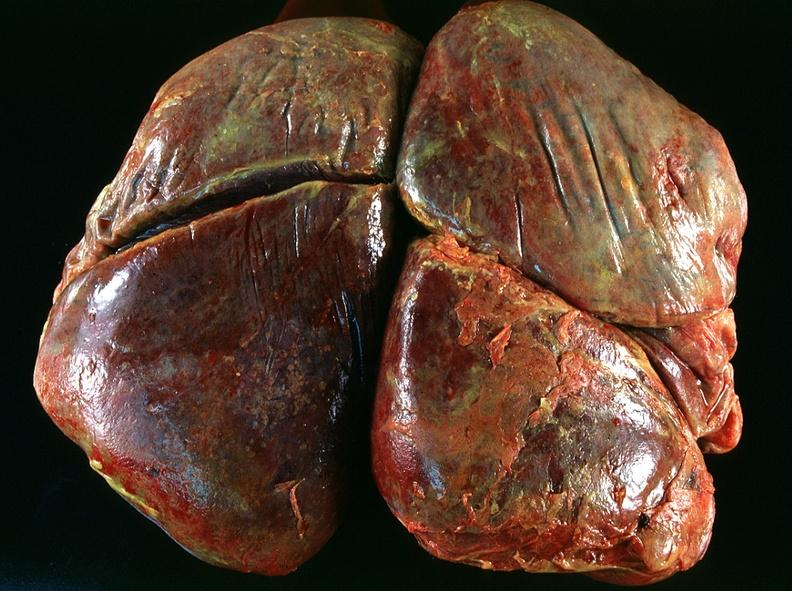how many antitrypsin does this image show lung, emphysema and pneumonia, alpha-deficiency?
Answer the question using a single word or phrase. 1 